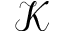<formula> <loc_0><loc_0><loc_500><loc_500>\mathcal { K }</formula> 